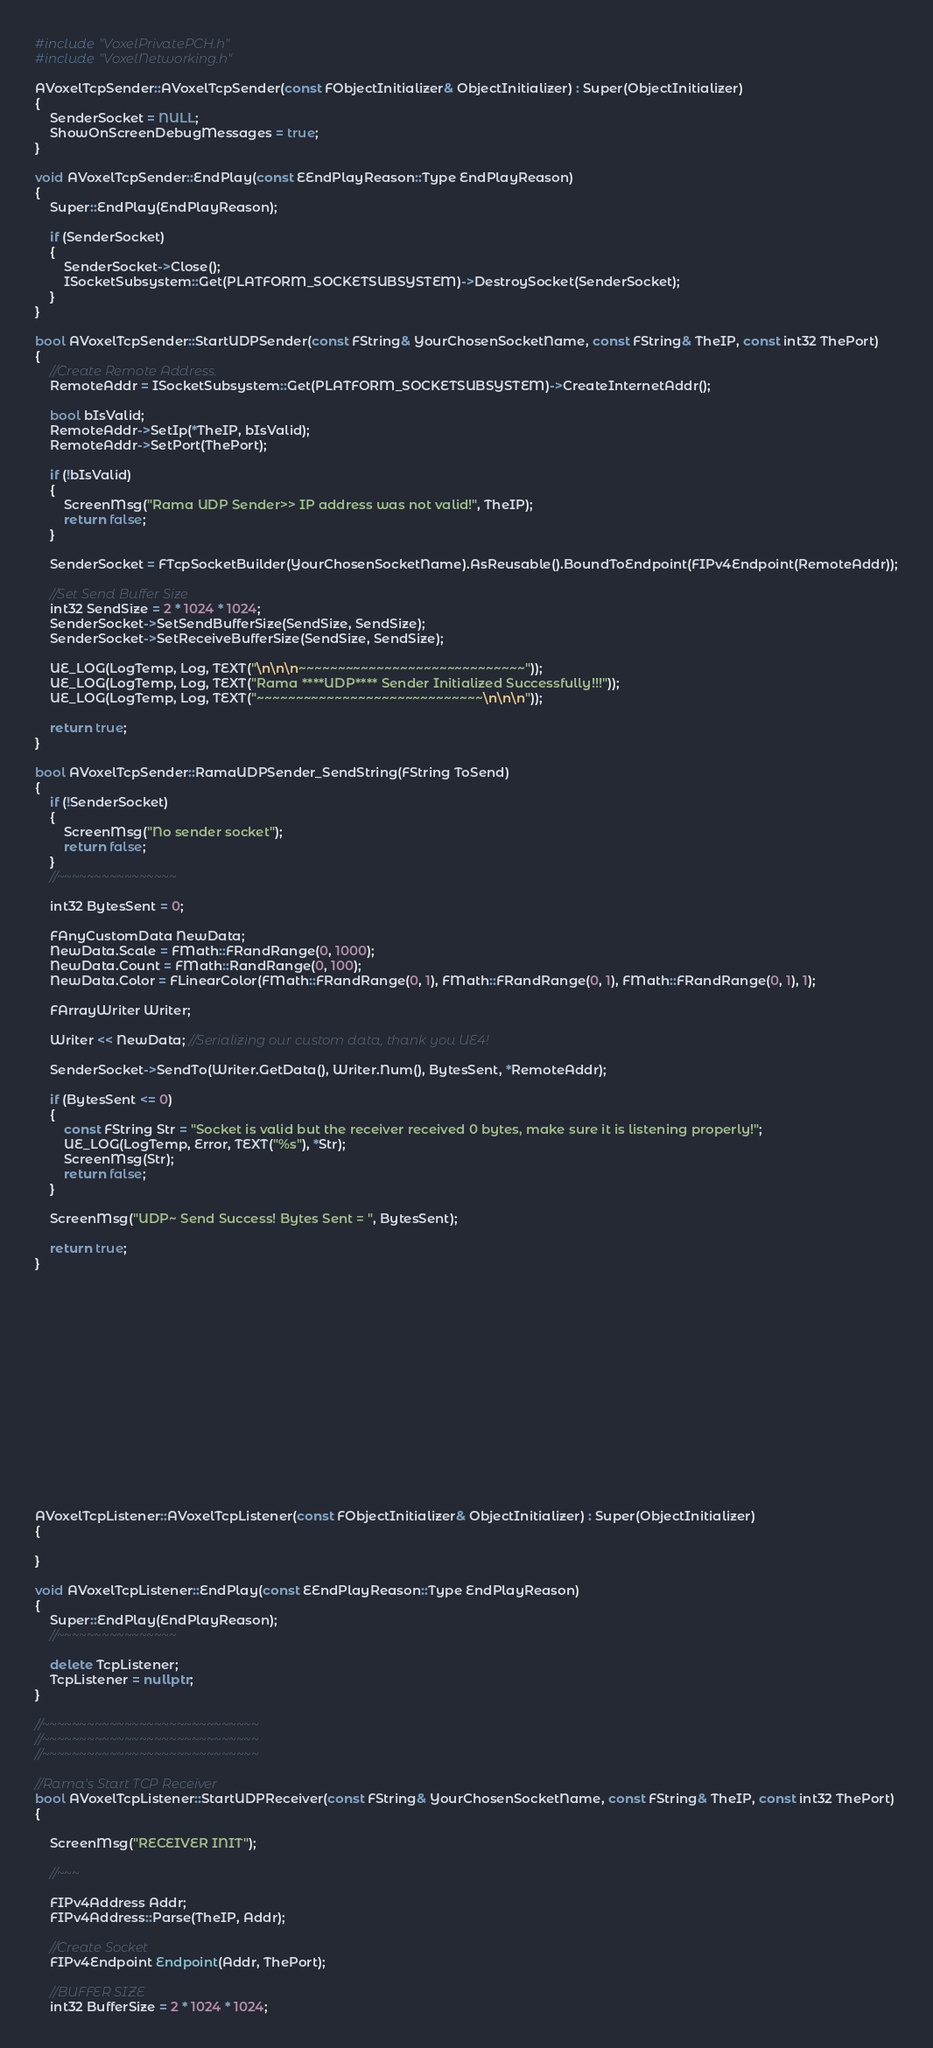Convert code to text. <code><loc_0><loc_0><loc_500><loc_500><_C++_>#include "VoxelPrivatePCH.h"
#include "VoxelNetworking.h"

AVoxelTcpSender::AVoxelTcpSender(const FObjectInitializer& ObjectInitializer) : Super(ObjectInitializer)
{
	SenderSocket = NULL;
	ShowOnScreenDebugMessages = true;
}

void AVoxelTcpSender::EndPlay(const EEndPlayReason::Type EndPlayReason)
{
	Super::EndPlay(EndPlayReason);

	if (SenderSocket)
	{
		SenderSocket->Close();
		ISocketSubsystem::Get(PLATFORM_SOCKETSUBSYSTEM)->DestroySocket(SenderSocket);
	}
}

bool AVoxelTcpSender::StartUDPSender(const FString& YourChosenSocketName, const FString& TheIP, const int32 ThePort)
{
	//Create Remote Address.
	RemoteAddr = ISocketSubsystem::Get(PLATFORM_SOCKETSUBSYSTEM)->CreateInternetAddr();

	bool bIsValid;
	RemoteAddr->SetIp(*TheIP, bIsValid);
	RemoteAddr->SetPort(ThePort);

	if (!bIsValid)
	{
		ScreenMsg("Rama UDP Sender>> IP address was not valid!", TheIP);
		return false;
	}

	SenderSocket = FTcpSocketBuilder(YourChosenSocketName).AsReusable().BoundToEndpoint(FIPv4Endpoint(RemoteAddr));

	//Set Send Buffer Size
	int32 SendSize = 2 * 1024 * 1024;
	SenderSocket->SetSendBufferSize(SendSize, SendSize);
	SenderSocket->SetReceiveBufferSize(SendSize, SendSize);

	UE_LOG(LogTemp, Log, TEXT("\n\n\n~~~~~~~~~~~~~~~~~~~~~~~~~~~~~"));
	UE_LOG(LogTemp, Log, TEXT("Rama ****UDP**** Sender Initialized Successfully!!!"));
	UE_LOG(LogTemp, Log, TEXT("~~~~~~~~~~~~~~~~~~~~~~~~~~~~~\n\n\n"));

	return true;
}

bool AVoxelTcpSender::RamaUDPSender_SendString(FString ToSend)
{
	if (!SenderSocket)
	{
		ScreenMsg("No sender socket");
		return false;
	}
	//~~~~~~~~~~~~~~~~

	int32 BytesSent = 0;

	FAnyCustomData NewData;
	NewData.Scale = FMath::FRandRange(0, 1000);
	NewData.Count = FMath::RandRange(0, 100);
	NewData.Color = FLinearColor(FMath::FRandRange(0, 1), FMath::FRandRange(0, 1), FMath::FRandRange(0, 1), 1);

	FArrayWriter Writer;

	Writer << NewData; //Serializing our custom data, thank you UE4!

	SenderSocket->SendTo(Writer.GetData(), Writer.Num(), BytesSent, *RemoteAddr);

	if (BytesSent <= 0)
	{
		const FString Str = "Socket is valid but the receiver received 0 bytes, make sure it is listening properly!";
		UE_LOG(LogTemp, Error, TEXT("%s"), *Str);
		ScreenMsg(Str);
		return false;
	}

	ScreenMsg("UDP~ Send Success! Bytes Sent = ", BytesSent);

	return true;
}
















AVoxelTcpListener::AVoxelTcpListener(const FObjectInitializer& ObjectInitializer) : Super(ObjectInitializer)
{
	
}

void AVoxelTcpListener::EndPlay(const EEndPlayReason::Type EndPlayReason)
{
	Super::EndPlay(EndPlayReason);
	//~~~~~~~~~~~~~~~~

	delete TcpListener;
	TcpListener = nullptr;
}

//~~~~~~~~~~~~~~~~~~~~~~~~~~~~~
//~~~~~~~~~~~~~~~~~~~~~~~~~~~~~
//~~~~~~~~~~~~~~~~~~~~~~~~~~~~~

//Rama's Start TCP Receiver
bool AVoxelTcpListener::StartUDPReceiver(const FString& YourChosenSocketName, const FString& TheIP, const int32 ThePort)
{

	ScreenMsg("RECEIVER INIT");

	//~~~

	FIPv4Address Addr;
	FIPv4Address::Parse(TheIP, Addr);

	//Create Socket
	FIPv4Endpoint Endpoint(Addr, ThePort);

	//BUFFER SIZE
	int32 BufferSize = 2 * 1024 * 1024;
</code> 